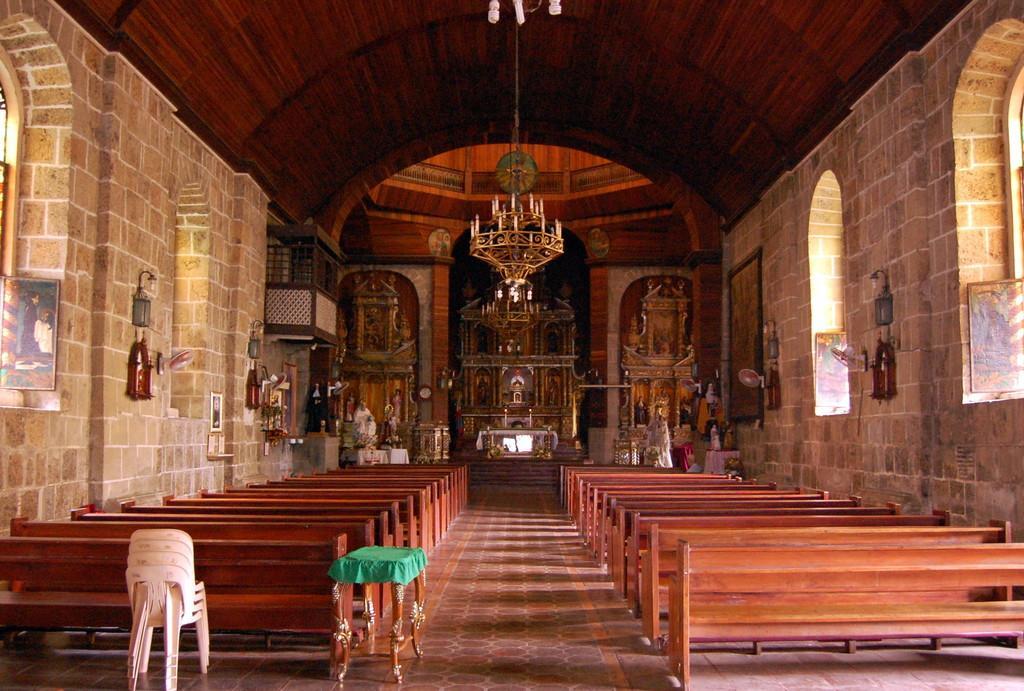Can you describe this image briefly? In this picture we can see chairs, stool, benches, chandelier light, statues, photo frames and in the background we can see a wall, roof, windows and some objects. 